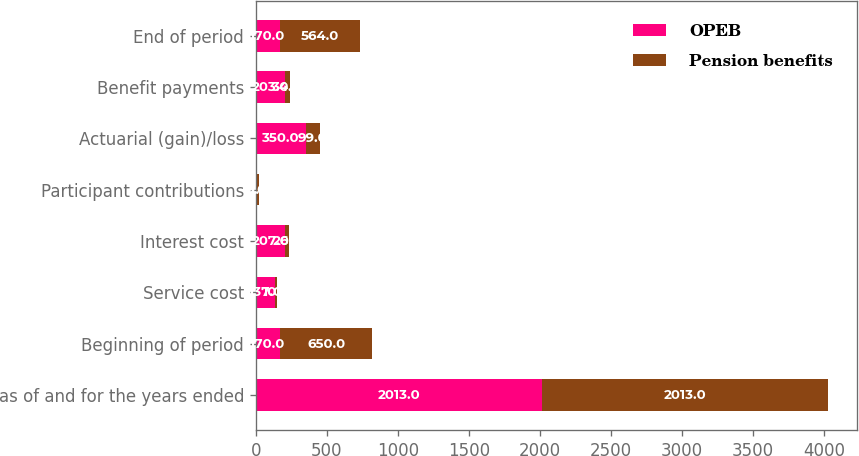Convert chart to OTSL. <chart><loc_0><loc_0><loc_500><loc_500><stacked_bar_chart><ecel><fcel>as of and for the years ended<fcel>Beginning of period<fcel>Service cost<fcel>Interest cost<fcel>Participant contributions<fcel>Actuarial (gain)/loss<fcel>Benefit payments<fcel>End of period<nl><fcel>OPEB<fcel>2013<fcel>170<fcel>137<fcel>207<fcel>9<fcel>350<fcel>203<fcel>170<nl><fcel>Pension benefits<fcel>2013<fcel>650<fcel>10<fcel>26<fcel>11<fcel>99<fcel>34<fcel>564<nl></chart> 